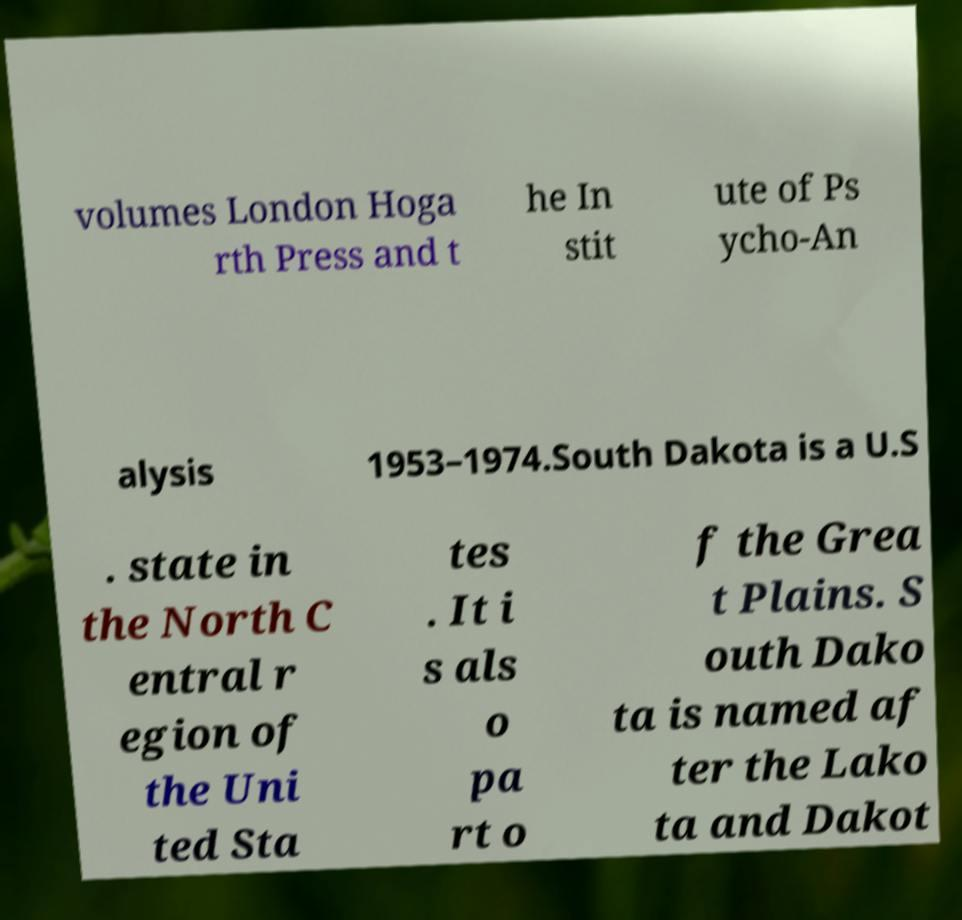I need the written content from this picture converted into text. Can you do that? volumes London Hoga rth Press and t he In stit ute of Ps ycho-An alysis 1953–1974.South Dakota is a U.S . state in the North C entral r egion of the Uni ted Sta tes . It i s als o pa rt o f the Grea t Plains. S outh Dako ta is named af ter the Lako ta and Dakot 